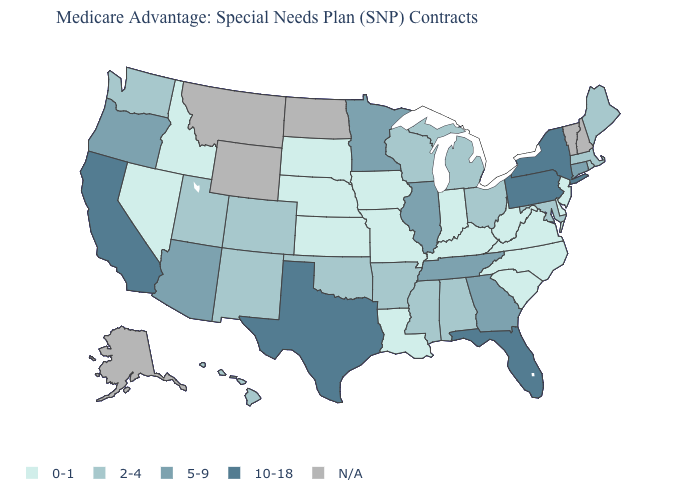What is the highest value in the Northeast ?
Quick response, please. 10-18. Is the legend a continuous bar?
Short answer required. No. What is the value of Alaska?
Be succinct. N/A. What is the value of South Dakota?
Concise answer only. 0-1. Among the states that border Maryland , which have the highest value?
Concise answer only. Pennsylvania. What is the value of Ohio?
Be succinct. 2-4. What is the value of South Carolina?
Quick response, please. 0-1. Name the states that have a value in the range 5-9?
Be succinct. Arizona, Connecticut, Georgia, Illinois, Minnesota, Oregon, Tennessee. Name the states that have a value in the range 10-18?
Be succinct. California, Florida, New York, Pennsylvania, Texas. What is the value of Idaho?
Give a very brief answer. 0-1. Does the map have missing data?
Give a very brief answer. Yes. Name the states that have a value in the range 5-9?
Keep it brief. Arizona, Connecticut, Georgia, Illinois, Minnesota, Oregon, Tennessee. What is the lowest value in the Northeast?
Concise answer only. 0-1. Does the map have missing data?
Give a very brief answer. Yes. Does Mississippi have the highest value in the USA?
Give a very brief answer. No. 